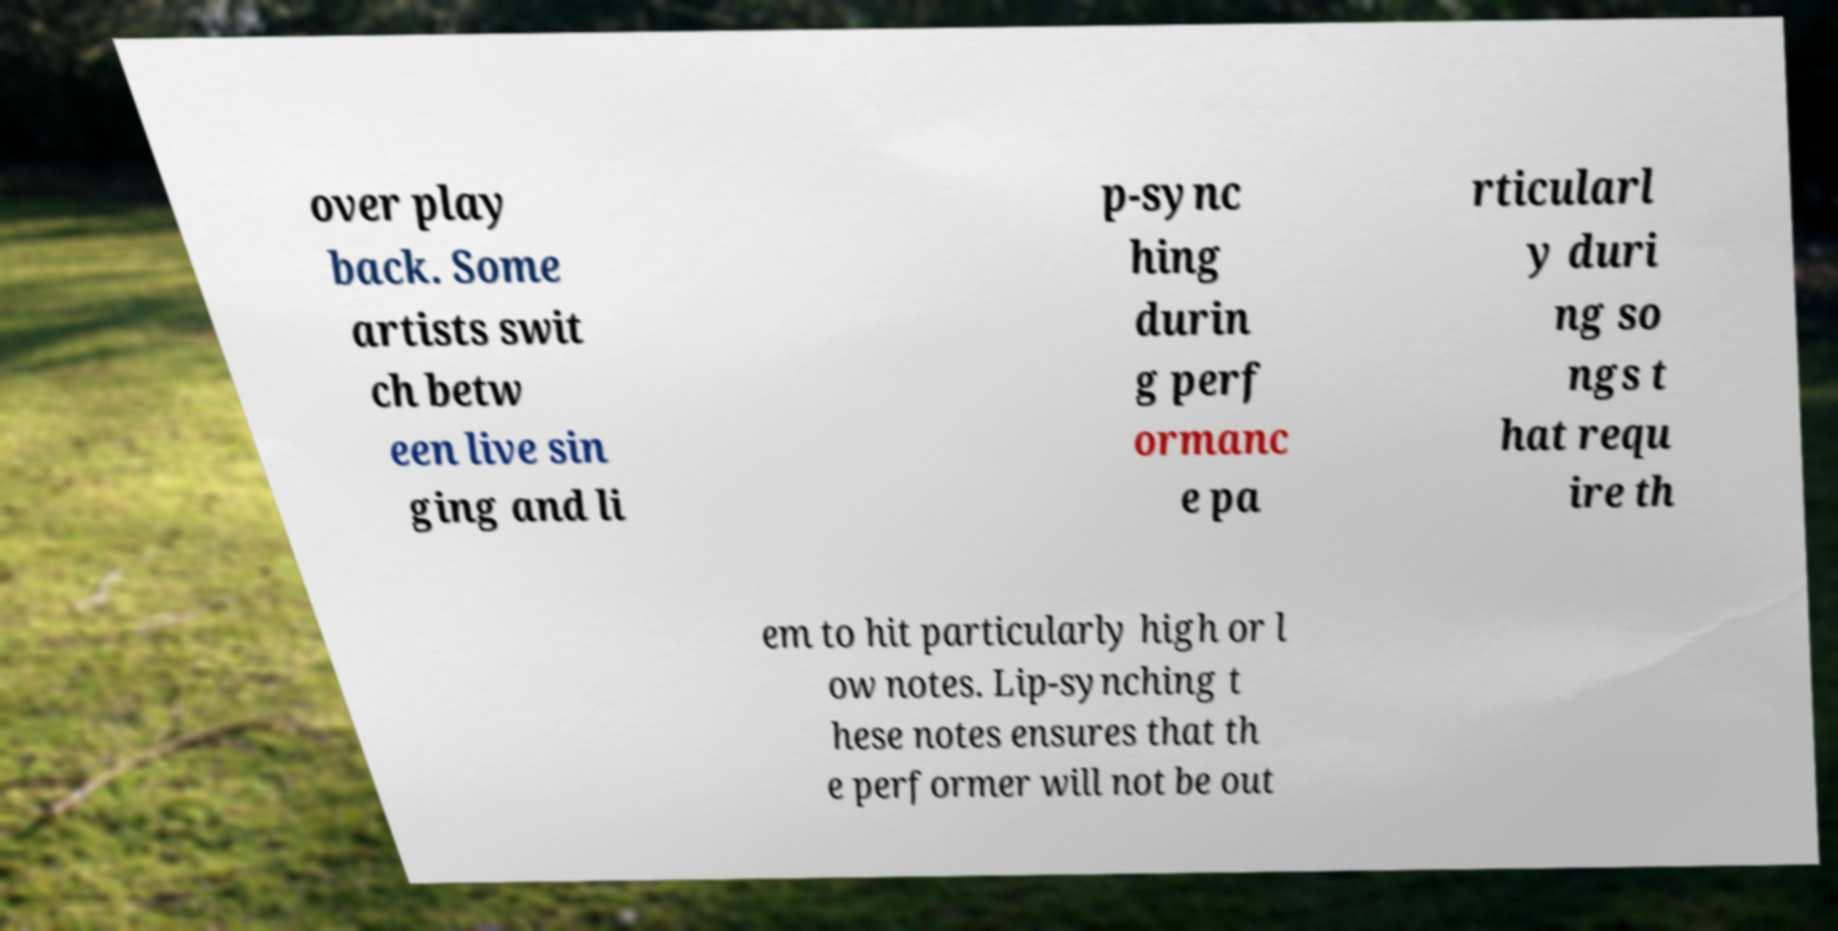For documentation purposes, I need the text within this image transcribed. Could you provide that? over play back. Some artists swit ch betw een live sin ging and li p-sync hing durin g perf ormanc e pa rticularl y duri ng so ngs t hat requ ire th em to hit particularly high or l ow notes. Lip-synching t hese notes ensures that th e performer will not be out 